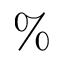<formula> <loc_0><loc_0><loc_500><loc_500>\%</formula> 